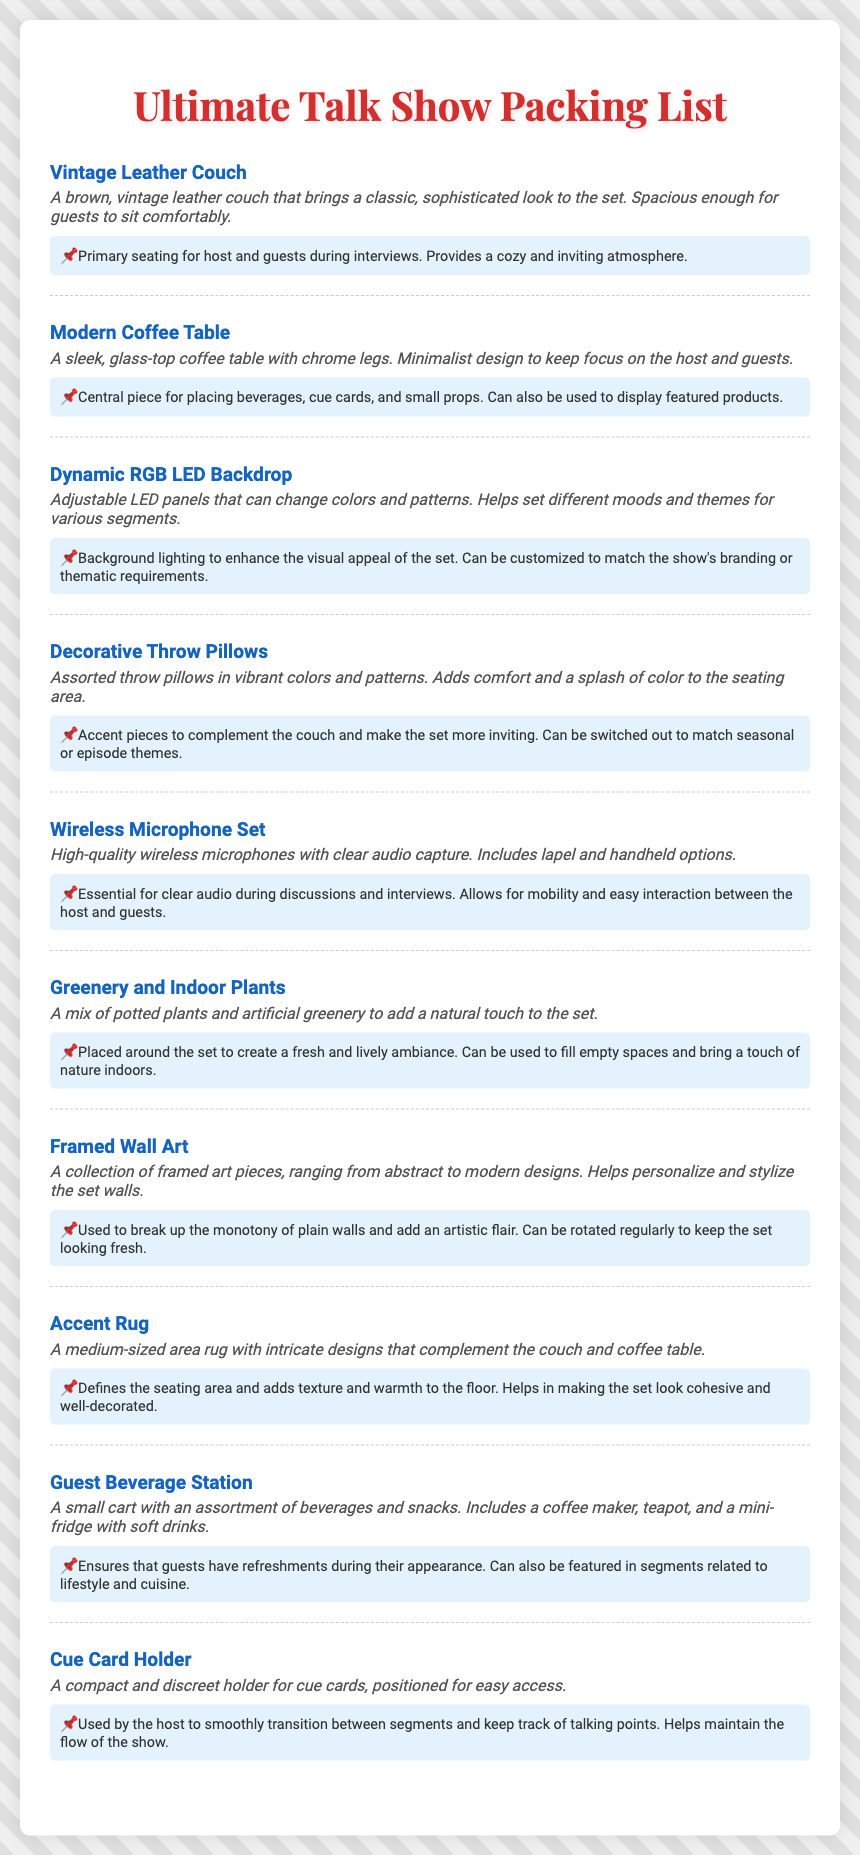What is the primary seating item listed? The item description specifically states it is a couch designed for seating, which is the Vintage Leather Couch.
Answer: Vintage Leather Couch How many types of microphones are included in the set? The document lists both lapel and handheld options for microphones, indicating two types.
Answer: Two types What is the function of the Dynamic RGB LED Backdrop? The use case describes it as background lighting to enhance the visual appeal of the set, which defines its function.
Answer: Background lighting What color palette do the Decorative Throw Pillows feature? The description mentions vibrant colors, summarizing the aesthetic of the pillows.
Answer: Vibrant colors What is the purpose of the Guest Beverage Station? The use case outlines that it ensures guests have refreshments during their appearance.
Answer: Refreshments Which item is meant for placing beverages and cue cards? The description of the Modern Coffee Table indicates it serves this purpose.
Answer: Modern Coffee Table What visual effect does the Accent Rug provide? The use case indicates that it adds texture and warmth to the floor, highlighting its contribution to the set's appearance.
Answer: Texture and warmth How does the Framed Wall Art affect the set? The use case explains that it adds an artistic flair to the set walls, indicating its effect.
Answer: Artistic flair 